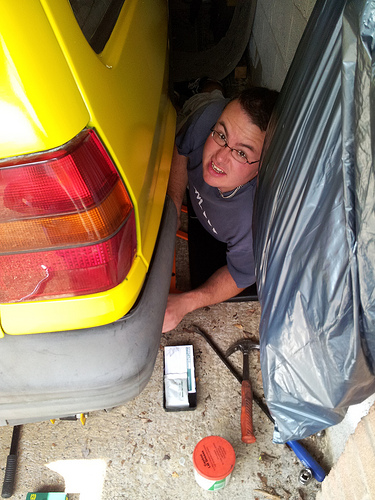<image>
Is there a man in front of the car? No. The man is not in front of the car. The spatial positioning shows a different relationship between these objects. 